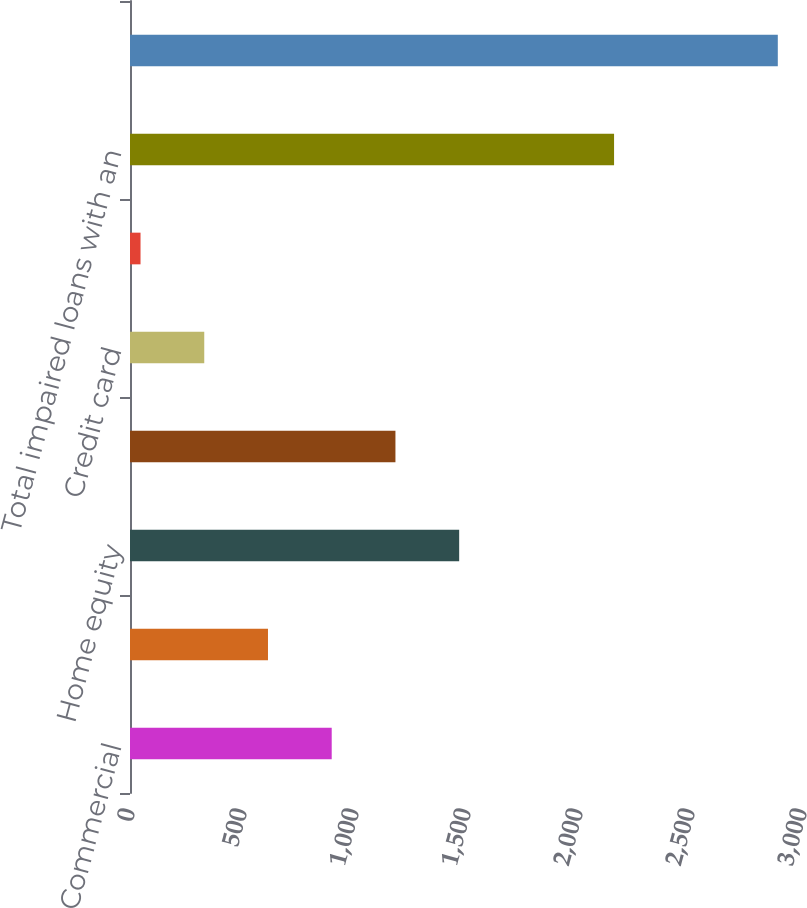Convert chart. <chart><loc_0><loc_0><loc_500><loc_500><bar_chart><fcel>Commercial<fcel>Commercial real estate<fcel>Home equity<fcel>Residential real estate<fcel>Credit card<fcel>Other consumer<fcel>Total impaired loans with an<fcel>Total impaired loans<nl><fcel>900.5<fcel>616<fcel>1469.5<fcel>1185<fcel>331.5<fcel>47<fcel>2161<fcel>2892<nl></chart> 